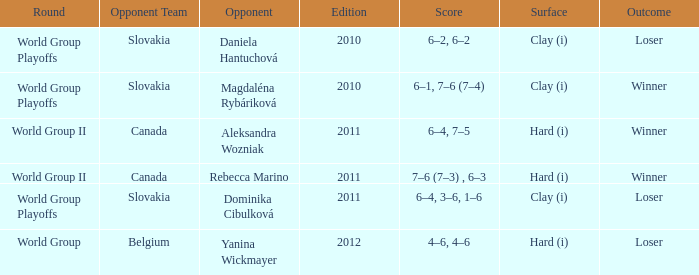What was the score when the opposing team was from Belgium? 4–6, 4–6. 